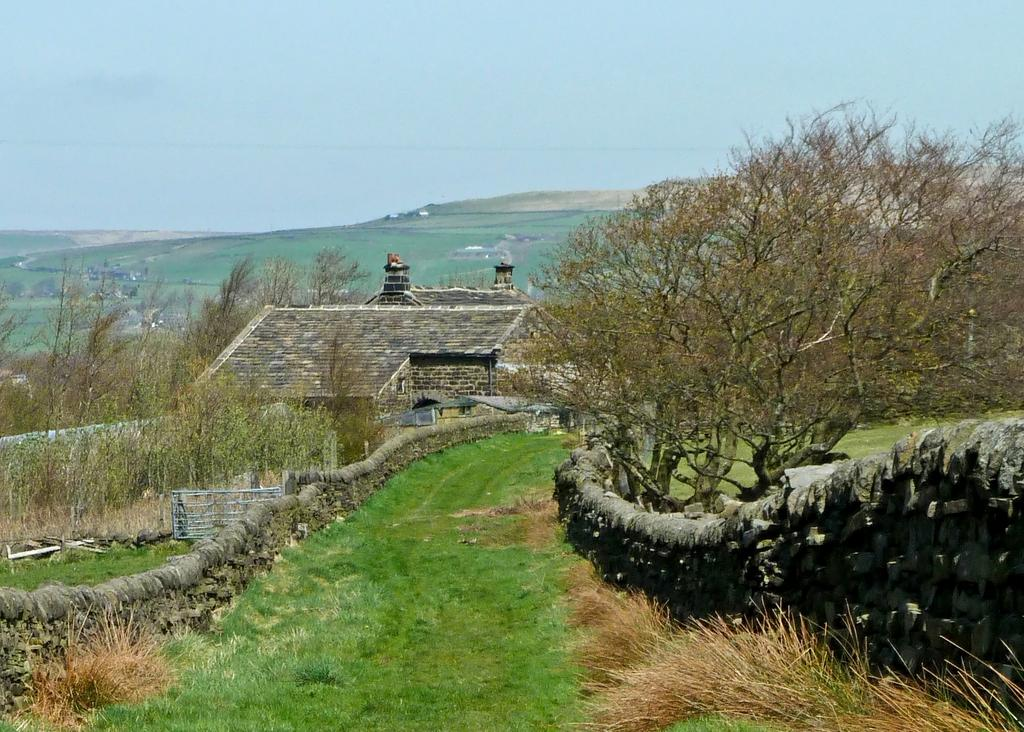What type of structure is present in the image? There is a building in the image. What can be seen on the ground in the image? There are trees and grass on the ground in the image. What is visible in the background of the image? There are mountains visible in the background of the image. What is visible at the top of the image? The sky is visible at the top of the image. What type of harmony is being played by the trees in the image? There is no harmony being played by the trees in the image, as trees do not produce music. 